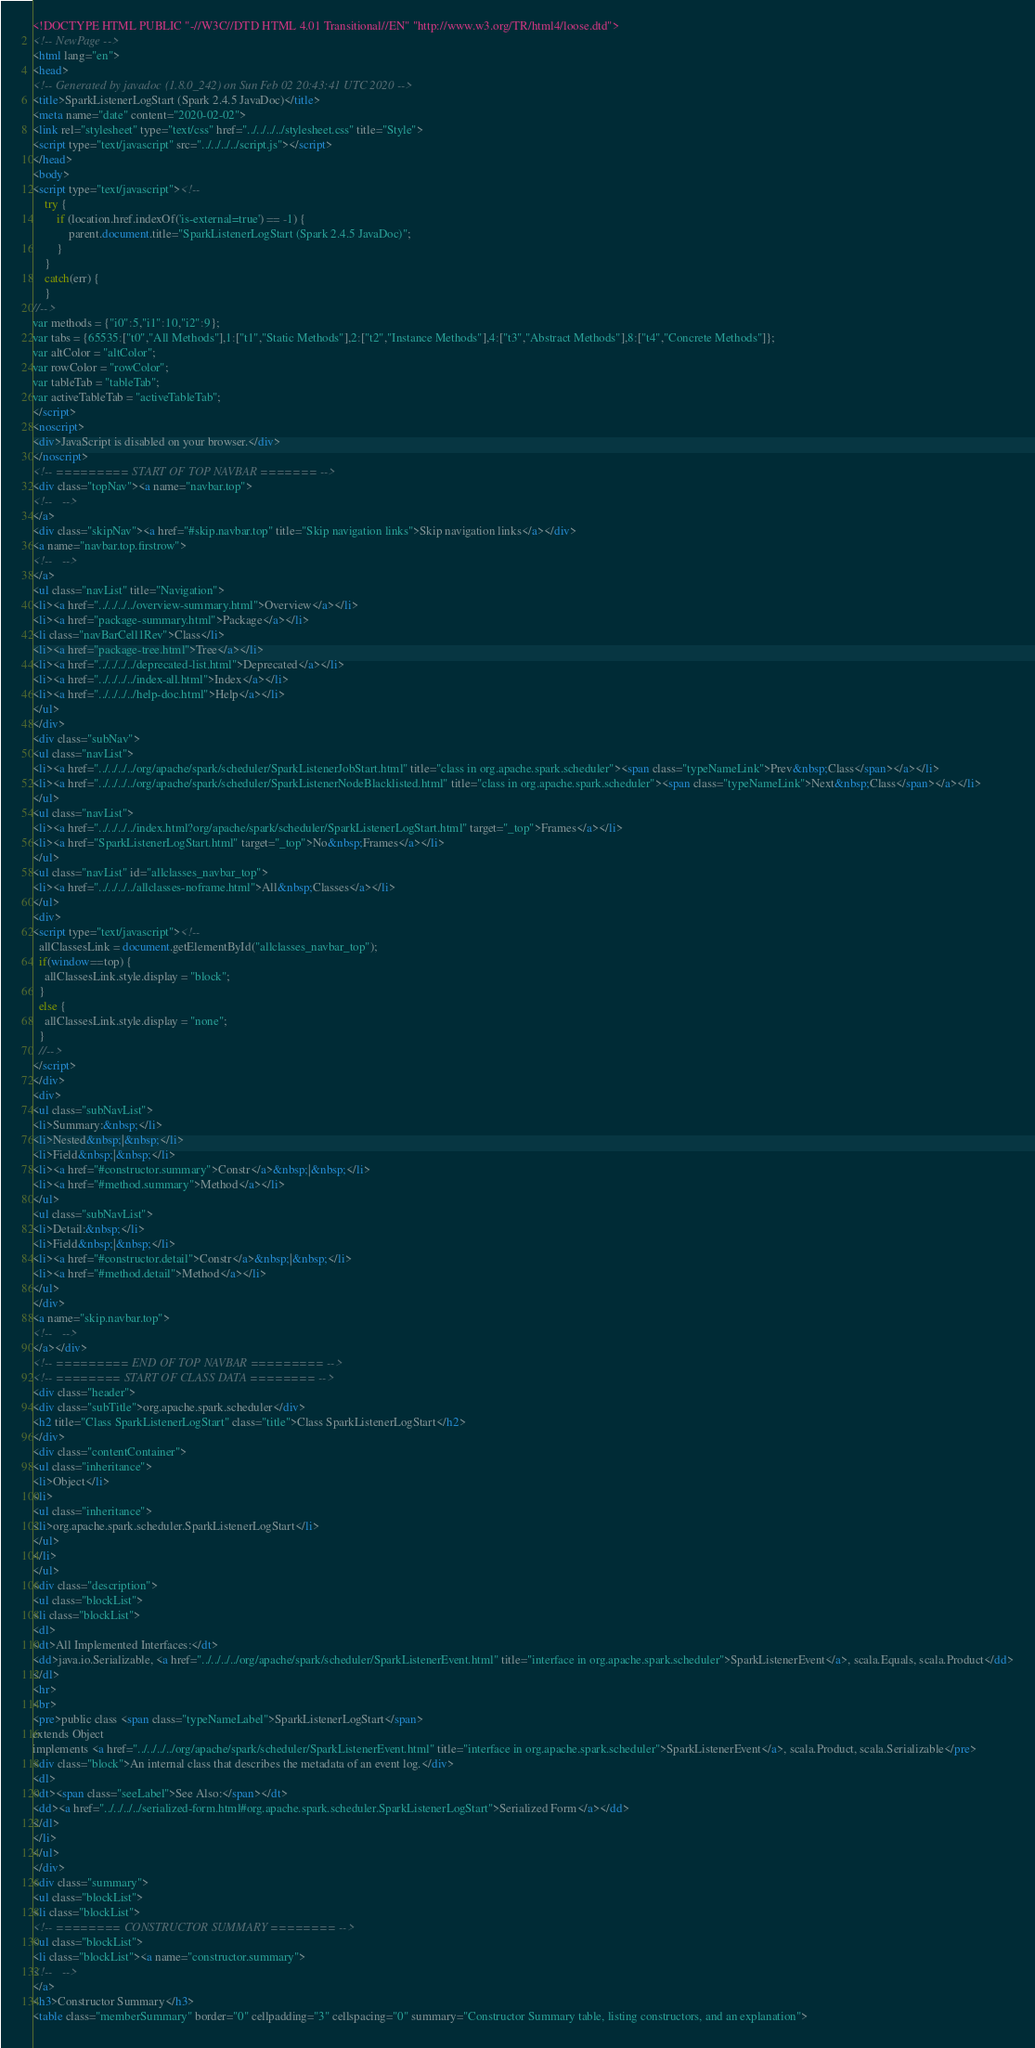Convert code to text. <code><loc_0><loc_0><loc_500><loc_500><_HTML_><!DOCTYPE HTML PUBLIC "-//W3C//DTD HTML 4.01 Transitional//EN" "http://www.w3.org/TR/html4/loose.dtd">
<!-- NewPage -->
<html lang="en">
<head>
<!-- Generated by javadoc (1.8.0_242) on Sun Feb 02 20:43:41 UTC 2020 -->
<title>SparkListenerLogStart (Spark 2.4.5 JavaDoc)</title>
<meta name="date" content="2020-02-02">
<link rel="stylesheet" type="text/css" href="../../../../stylesheet.css" title="Style">
<script type="text/javascript" src="../../../../script.js"></script>
</head>
<body>
<script type="text/javascript"><!--
    try {
        if (location.href.indexOf('is-external=true') == -1) {
            parent.document.title="SparkListenerLogStart (Spark 2.4.5 JavaDoc)";
        }
    }
    catch(err) {
    }
//-->
var methods = {"i0":5,"i1":10,"i2":9};
var tabs = {65535:["t0","All Methods"],1:["t1","Static Methods"],2:["t2","Instance Methods"],4:["t3","Abstract Methods"],8:["t4","Concrete Methods"]};
var altColor = "altColor";
var rowColor = "rowColor";
var tableTab = "tableTab";
var activeTableTab = "activeTableTab";
</script>
<noscript>
<div>JavaScript is disabled on your browser.</div>
</noscript>
<!-- ========= START OF TOP NAVBAR ======= -->
<div class="topNav"><a name="navbar.top">
<!--   -->
</a>
<div class="skipNav"><a href="#skip.navbar.top" title="Skip navigation links">Skip navigation links</a></div>
<a name="navbar.top.firstrow">
<!--   -->
</a>
<ul class="navList" title="Navigation">
<li><a href="../../../../overview-summary.html">Overview</a></li>
<li><a href="package-summary.html">Package</a></li>
<li class="navBarCell1Rev">Class</li>
<li><a href="package-tree.html">Tree</a></li>
<li><a href="../../../../deprecated-list.html">Deprecated</a></li>
<li><a href="../../../../index-all.html">Index</a></li>
<li><a href="../../../../help-doc.html">Help</a></li>
</ul>
</div>
<div class="subNav">
<ul class="navList">
<li><a href="../../../../org/apache/spark/scheduler/SparkListenerJobStart.html" title="class in org.apache.spark.scheduler"><span class="typeNameLink">Prev&nbsp;Class</span></a></li>
<li><a href="../../../../org/apache/spark/scheduler/SparkListenerNodeBlacklisted.html" title="class in org.apache.spark.scheduler"><span class="typeNameLink">Next&nbsp;Class</span></a></li>
</ul>
<ul class="navList">
<li><a href="../../../../index.html?org/apache/spark/scheduler/SparkListenerLogStart.html" target="_top">Frames</a></li>
<li><a href="SparkListenerLogStart.html" target="_top">No&nbsp;Frames</a></li>
</ul>
<ul class="navList" id="allclasses_navbar_top">
<li><a href="../../../../allclasses-noframe.html">All&nbsp;Classes</a></li>
</ul>
<div>
<script type="text/javascript"><!--
  allClassesLink = document.getElementById("allclasses_navbar_top");
  if(window==top) {
    allClassesLink.style.display = "block";
  }
  else {
    allClassesLink.style.display = "none";
  }
  //-->
</script>
</div>
<div>
<ul class="subNavList">
<li>Summary:&nbsp;</li>
<li>Nested&nbsp;|&nbsp;</li>
<li>Field&nbsp;|&nbsp;</li>
<li><a href="#constructor.summary">Constr</a>&nbsp;|&nbsp;</li>
<li><a href="#method.summary">Method</a></li>
</ul>
<ul class="subNavList">
<li>Detail:&nbsp;</li>
<li>Field&nbsp;|&nbsp;</li>
<li><a href="#constructor.detail">Constr</a>&nbsp;|&nbsp;</li>
<li><a href="#method.detail">Method</a></li>
</ul>
</div>
<a name="skip.navbar.top">
<!--   -->
</a></div>
<!-- ========= END OF TOP NAVBAR ========= -->
<!-- ======== START OF CLASS DATA ======== -->
<div class="header">
<div class="subTitle">org.apache.spark.scheduler</div>
<h2 title="Class SparkListenerLogStart" class="title">Class SparkListenerLogStart</h2>
</div>
<div class="contentContainer">
<ul class="inheritance">
<li>Object</li>
<li>
<ul class="inheritance">
<li>org.apache.spark.scheduler.SparkListenerLogStart</li>
</ul>
</li>
</ul>
<div class="description">
<ul class="blockList">
<li class="blockList">
<dl>
<dt>All Implemented Interfaces:</dt>
<dd>java.io.Serializable, <a href="../../../../org/apache/spark/scheduler/SparkListenerEvent.html" title="interface in org.apache.spark.scheduler">SparkListenerEvent</a>, scala.Equals, scala.Product</dd>
</dl>
<hr>
<br>
<pre>public class <span class="typeNameLabel">SparkListenerLogStart</span>
extends Object
implements <a href="../../../../org/apache/spark/scheduler/SparkListenerEvent.html" title="interface in org.apache.spark.scheduler">SparkListenerEvent</a>, scala.Product, scala.Serializable</pre>
<div class="block">An internal class that describes the metadata of an event log.</div>
<dl>
<dt><span class="seeLabel">See Also:</span></dt>
<dd><a href="../../../../serialized-form.html#org.apache.spark.scheduler.SparkListenerLogStart">Serialized Form</a></dd>
</dl>
</li>
</ul>
</div>
<div class="summary">
<ul class="blockList">
<li class="blockList">
<!-- ======== CONSTRUCTOR SUMMARY ======== -->
<ul class="blockList">
<li class="blockList"><a name="constructor.summary">
<!--   -->
</a>
<h3>Constructor Summary</h3>
<table class="memberSummary" border="0" cellpadding="3" cellspacing="0" summary="Constructor Summary table, listing constructors, and an explanation"></code> 